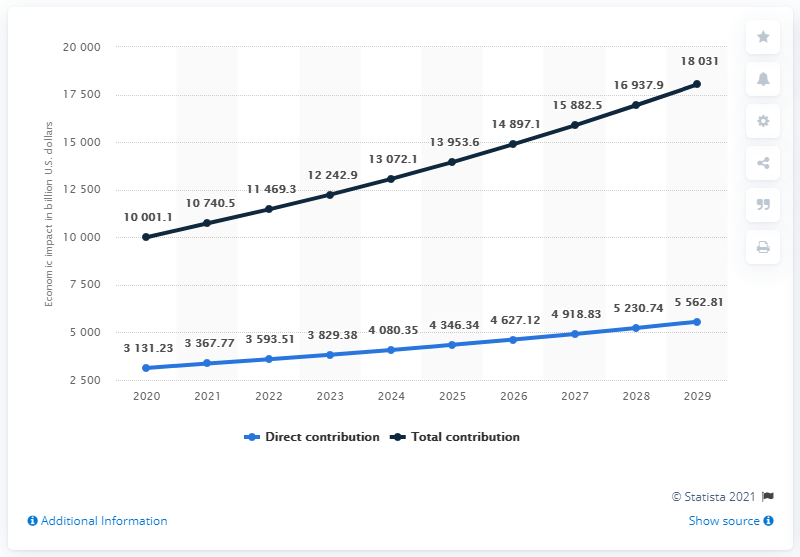Indicate a few pertinent items in this graphic. The average contribution made between 2028 and 2029 was 5,396.775. In the year that the blue line bar crossed the value of 5000, it was 2028. 